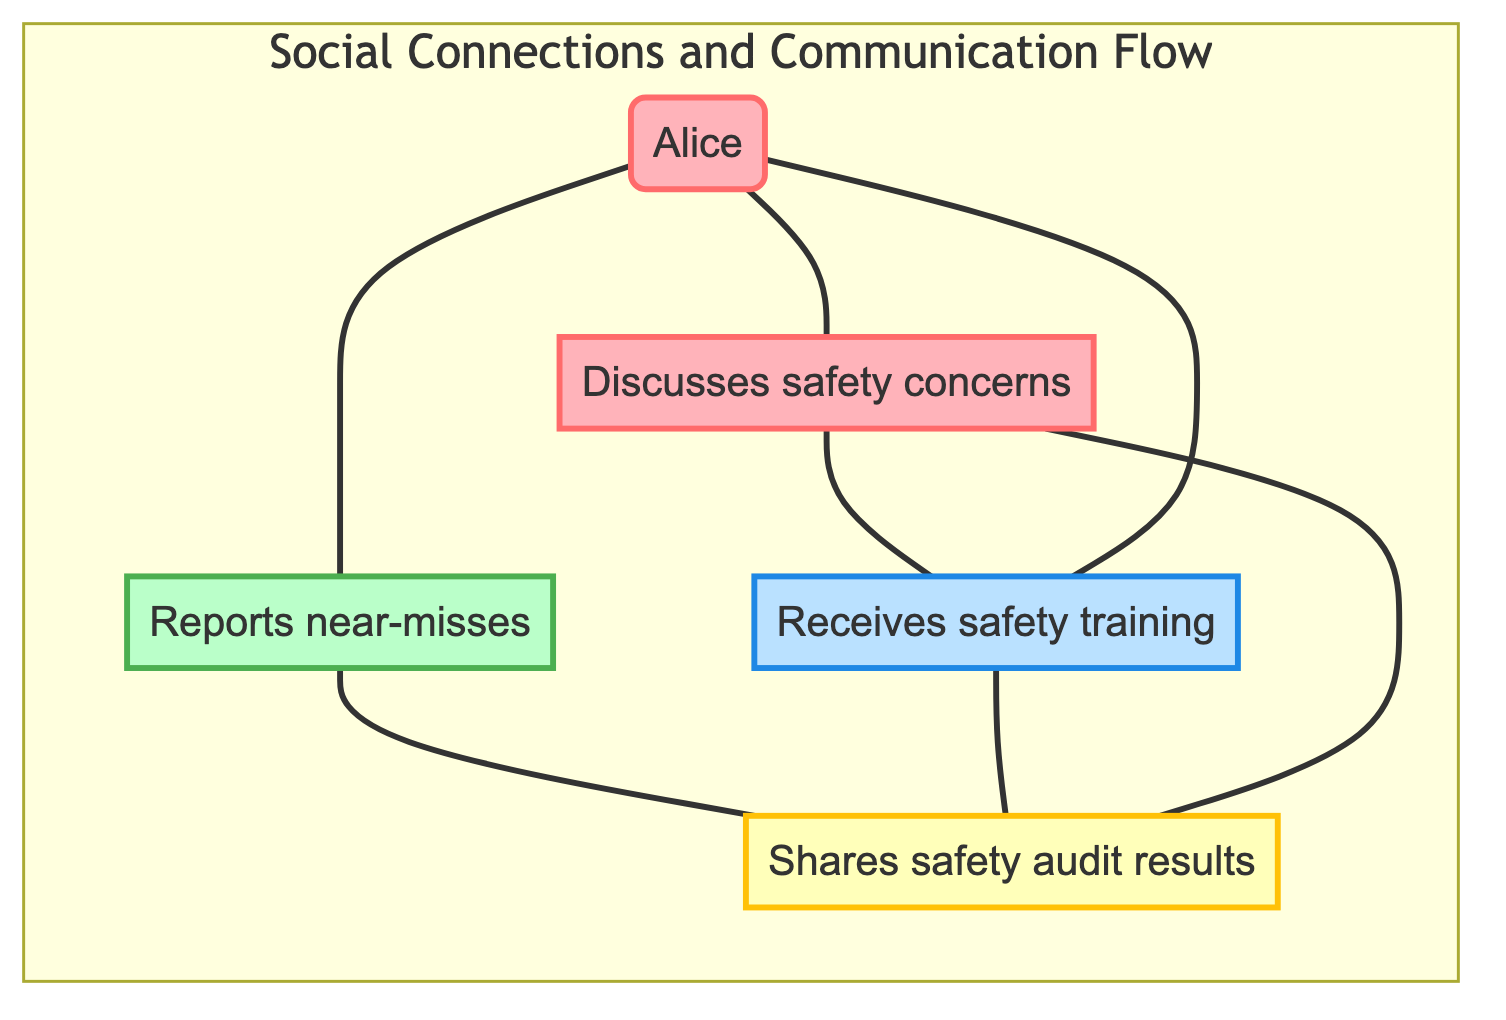1. Who discusses safety concerns? From the edges we see that Alice is connected to Bob with the label "Discusses safety concerns". Therefore, Alice is the one who discusses safety concerns with Bob.
Answer: Alice 2. How many edges are in the diagram? Counting the connections (edges) shown, there are a total of 7 connections.
Answer: 7 3. Which employee receives safety training? The edge between Alice and Dave is labeled "Receives safety training", indicating that Alice receives training from Dave.
Answer: Alice 4. Who escalates safety issues? The edge between Carol and Eve is labeled "Escalates safety issues", so Carol is the one who escalates these issues to Eve.
Answer: Carol 5. What role does Bob have in safety suggestions? There is a connection between Bob and Dave labeled "Submits safety suggestions", which means Bob's role is to submit these suggestions to Dave.
Answer: Submits safety suggestions 6. Who shares safety audit results? There is an edge indicating that Bob shares safety audit results with Eve, meaning Bob's responsibility is to communicate these results.
Answer: Bob 7. What is the relationship between Carol and Eve? The edge connecting Carol and Eve is labeled "Escalates safety issues", which shows that their relationship involves Carol escalating safety issues to Eve.
Answer: Escalates safety issues 8. Which node has the most connections? By analyzing the number of edges connected to each node, we determine that Alice has 3 connections, while Bob has 3 as well. So they share the most connections within this diagram.
Answer: Alice and Bob 9. Who provides safety updates? The edge connects Dave and Eve with the label "Provides safety updates", indicating that Dave is responsible for providing safety updates to Eve.
Answer: Dave 10. What type of diagram is this? This diagram's structure features nodes connected by edges without directed paths, classifying it as an undirected graph.
Answer: Undirected graph 